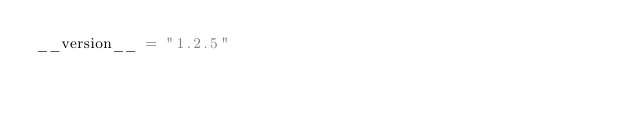<code> <loc_0><loc_0><loc_500><loc_500><_Python_>__version__ = "1.2.5"</code> 